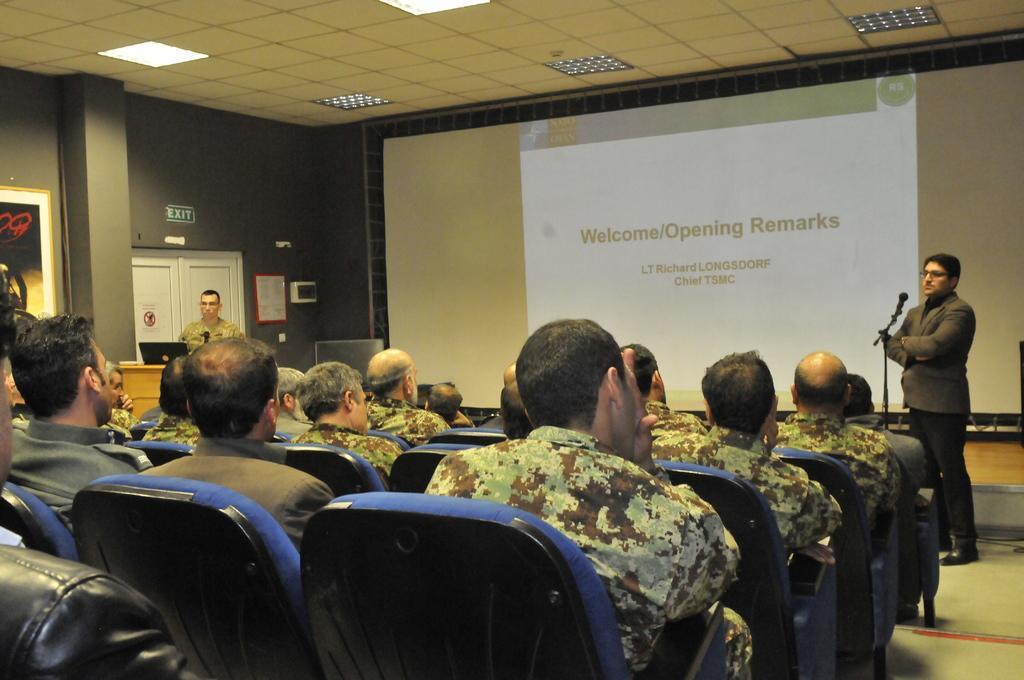How would you summarize this image in a sentence or two? There are few persons sitting on the chairs. On the right a man is standing on the floor at the mic which is on a stand. In the background on the left a man is standing at the podium and there is a laptop on the podium and we can see frames on the wall,screen,lights on the ceiling,and a small board on the wall,doors and other objects. 